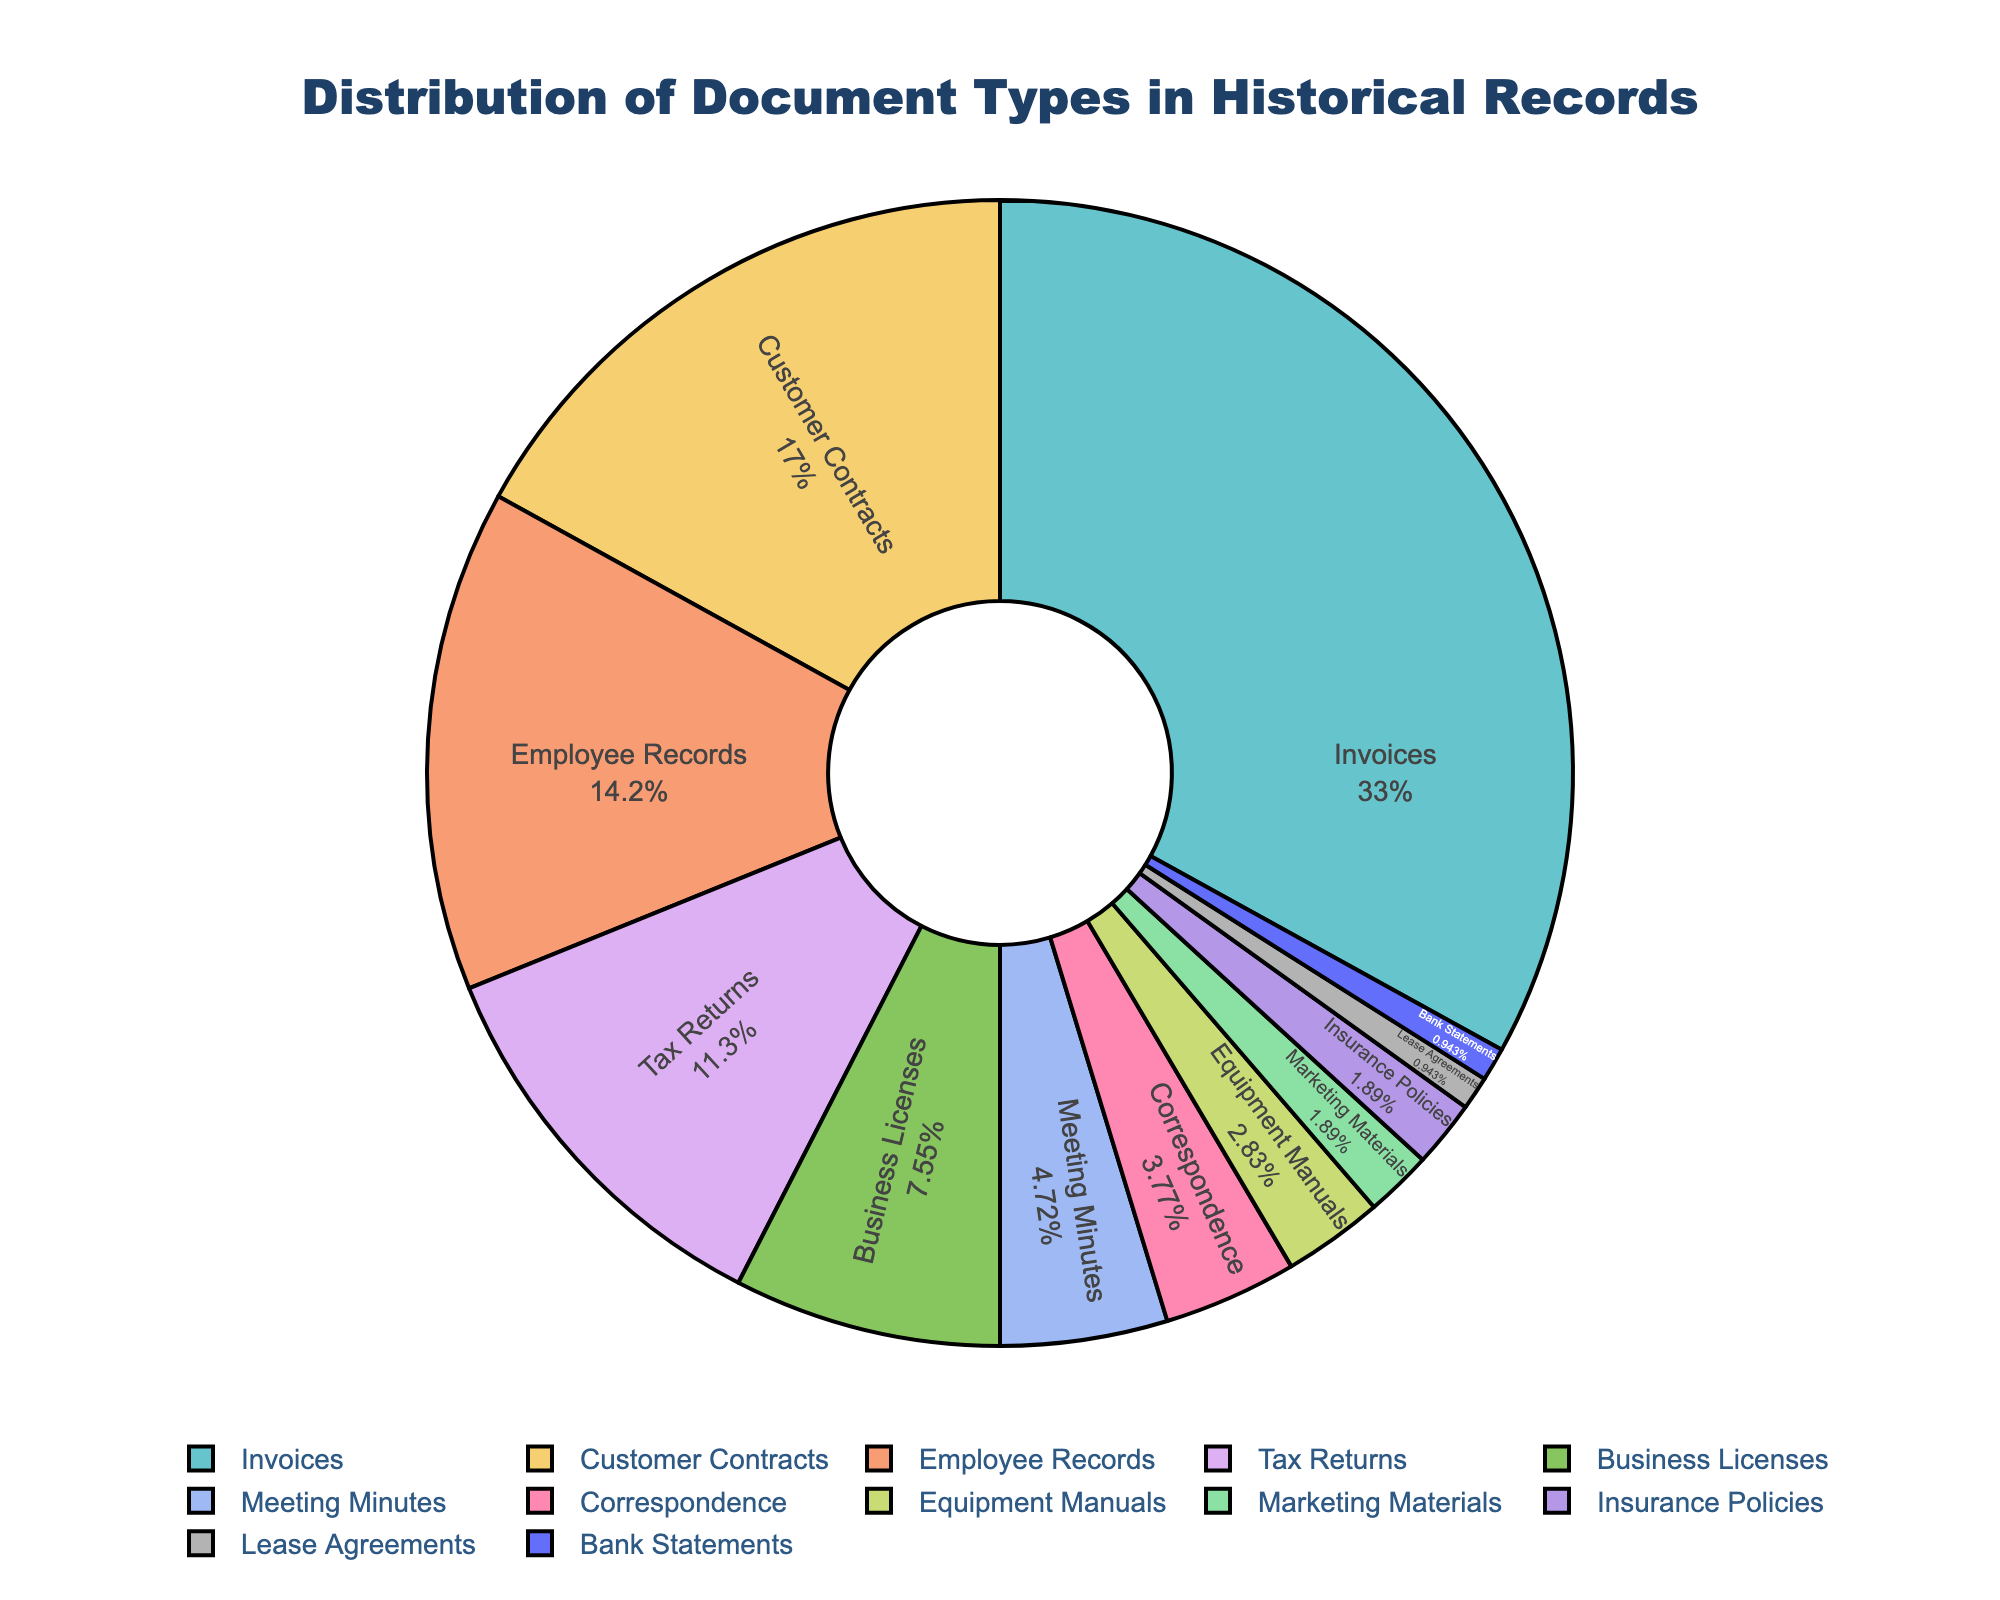Which document type has the highest percentage in the distribution? By observing the pie chart, we can see that "Invoices" occupies the largest segment, so it has the highest percentage.
Answer: Invoices What is the combined percentage of Customer Contracts and Employee Records? From the pie chart, Customer Contracts is 18% and Employee Records is 15%. So, the combined percentage is 18% + 15% = 33%.
Answer: 33% Are Customer Contracts more common than Tax Returns in the historical records? By comparing the sizes of the pie chart segments, Customer Contracts (18%) is larger than Tax Returns (12%), indicating that Customer Contracts are more common.
Answer: Yes What is the combined percentage of the three least common document types? The least common document types are Lease Agreements (1%), Bank Statements (1%), and Insurance Policies (2%). Adding their percentages gives us 1% + 1% + 2% = 4%.
Answer: 4% Which two document types together make up more than half of the historical records? By looking at the pie chart, Invoices (35%) and Customer Contracts (18%) together make 35% + 18% = 53%, which is more than half.
Answer: Invoices and Customer Contracts What is the difference in percentage between Employee Records and Business Licenses? Employee Records are 15%, and Business Licenses are 8%. The difference is 15% - 8% = 7%.
Answer: 7% How much more common are Equipment Manuals compared to Marketing Materials? Equipment Manuals are 3%, and Marketing Materials are 2%. The difference is 3% - 2% = 1%.
Answer: 1% If you add the percentage of Correspondence, Equipment Manuals, and Marketing Materials, do they make up more than 10% of the historical records? Correspondence is 4%, Equipment Manuals are 3%, and Marketing Materials are 2%. Adding these together gives 4% + 3% + 2% = 9%, which is not more than 10%.
Answer: No Which document type represents a lower percentage than Correspondence but higher than Bank Statements? Correspondence is 4%, and Bank Statements are 1%. The document type between these is Equipment Manuals, which is 3%.
Answer: Equipment Manuals 